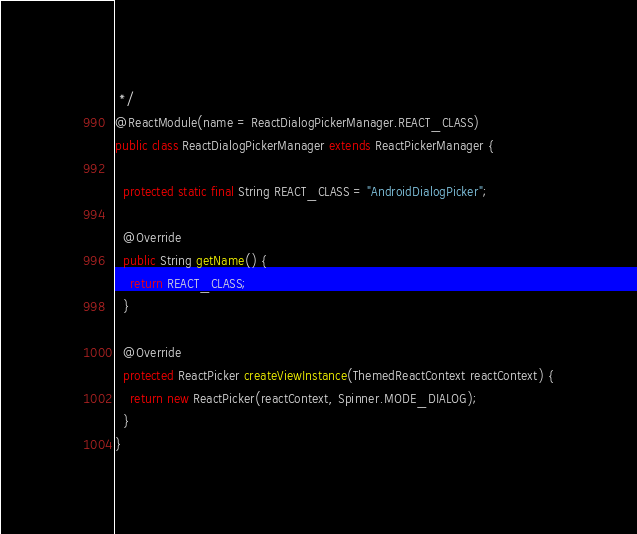Convert code to text. <code><loc_0><loc_0><loc_500><loc_500><_Java_> */
@ReactModule(name = ReactDialogPickerManager.REACT_CLASS)
public class ReactDialogPickerManager extends ReactPickerManager {

  protected static final String REACT_CLASS = "AndroidDialogPicker";

  @Override
  public String getName() {
    return REACT_CLASS;
  }

  @Override
  protected ReactPicker createViewInstance(ThemedReactContext reactContext) {
    return new ReactPicker(reactContext, Spinner.MODE_DIALOG);
  }
}
</code> 